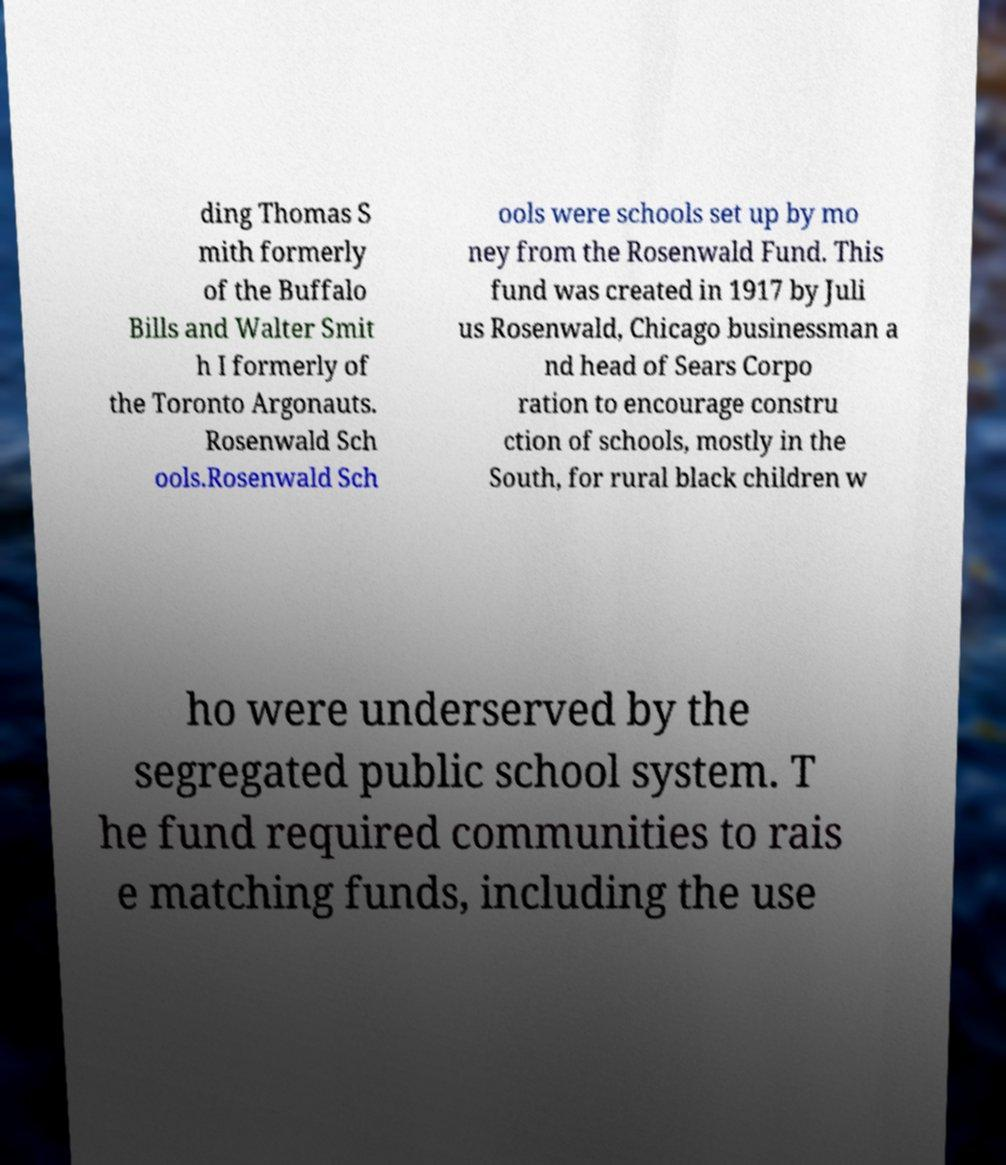Could you assist in decoding the text presented in this image and type it out clearly? ding Thomas S mith formerly of the Buffalo Bills and Walter Smit h I formerly of the Toronto Argonauts. Rosenwald Sch ools.Rosenwald Sch ools were schools set up by mo ney from the Rosenwald Fund. This fund was created in 1917 by Juli us Rosenwald, Chicago businessman a nd head of Sears Corpo ration to encourage constru ction of schools, mostly in the South, for rural black children w ho were underserved by the segregated public school system. T he fund required communities to rais e matching funds, including the use 